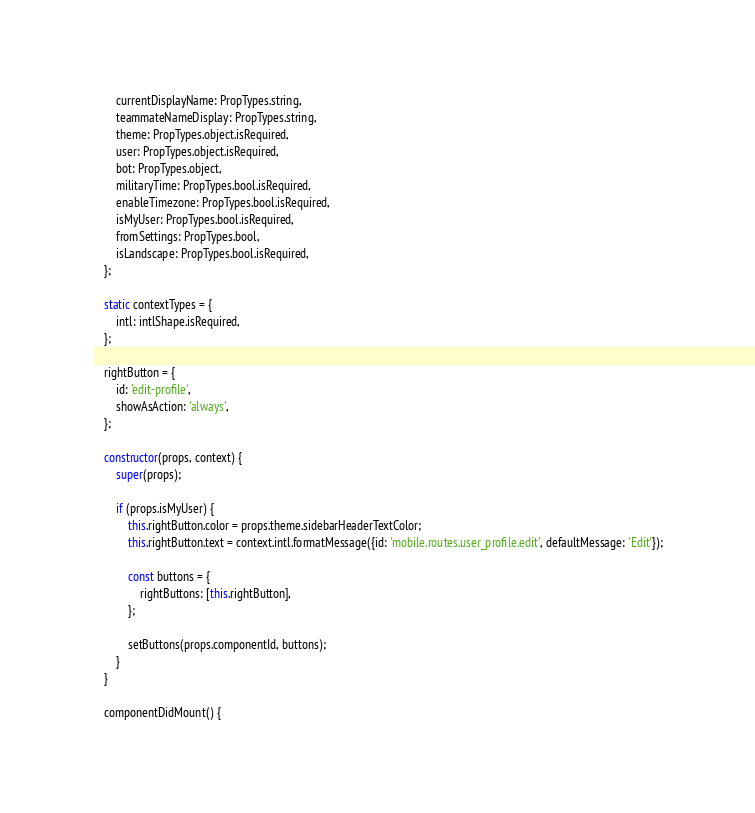Convert code to text. <code><loc_0><loc_0><loc_500><loc_500><_JavaScript_>        currentDisplayName: PropTypes.string,
        teammateNameDisplay: PropTypes.string,
        theme: PropTypes.object.isRequired,
        user: PropTypes.object.isRequired,
        bot: PropTypes.object,
        militaryTime: PropTypes.bool.isRequired,
        enableTimezone: PropTypes.bool.isRequired,
        isMyUser: PropTypes.bool.isRequired,
        fromSettings: PropTypes.bool,
        isLandscape: PropTypes.bool.isRequired,
    };

    static contextTypes = {
        intl: intlShape.isRequired,
    };

    rightButton = {
        id: 'edit-profile',
        showAsAction: 'always',
    };

    constructor(props, context) {
        super(props);

        if (props.isMyUser) {
            this.rightButton.color = props.theme.sidebarHeaderTextColor;
            this.rightButton.text = context.intl.formatMessage({id: 'mobile.routes.user_profile.edit', defaultMessage: 'Edit'});

            const buttons = {
                rightButtons: [this.rightButton],
            };

            setButtons(props.componentId, buttons);
        }
    }

    componentDidMount() {</code> 